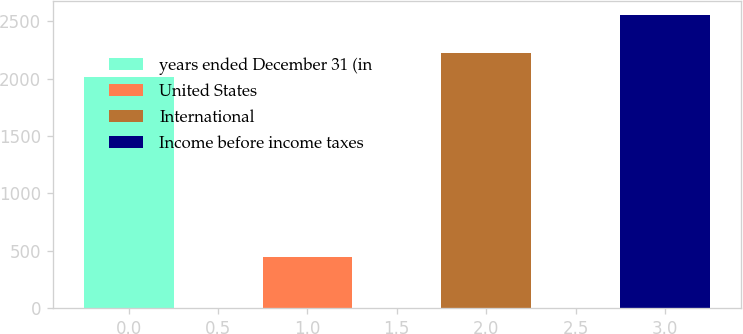Convert chart. <chart><loc_0><loc_0><loc_500><loc_500><bar_chart><fcel>years ended December 31 (in<fcel>United States<fcel>International<fcel>Income before income taxes<nl><fcel>2013<fcel>446<fcel>2223.3<fcel>2549<nl></chart> 